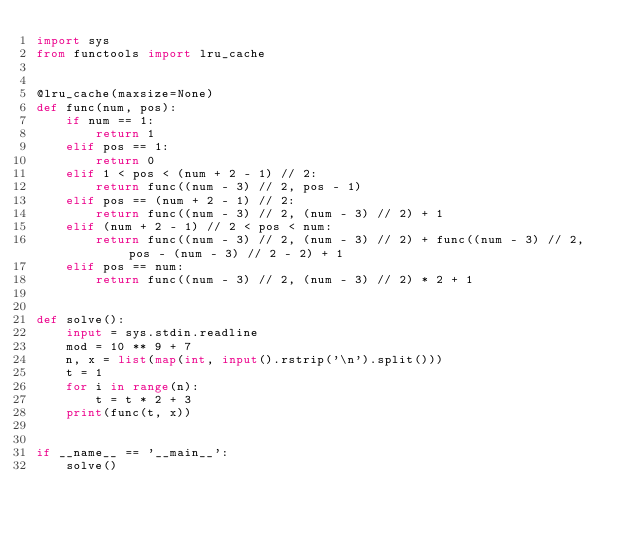<code> <loc_0><loc_0><loc_500><loc_500><_Python_>import sys
from functools import lru_cache


@lru_cache(maxsize=None)
def func(num, pos):
    if num == 1:
        return 1
    elif pos == 1:
        return 0
    elif 1 < pos < (num + 2 - 1) // 2:
        return func((num - 3) // 2, pos - 1)
    elif pos == (num + 2 - 1) // 2:
        return func((num - 3) // 2, (num - 3) // 2) + 1
    elif (num + 2 - 1) // 2 < pos < num:
        return func((num - 3) // 2, (num - 3) // 2) + func((num - 3) // 2, pos - (num - 3) // 2 - 2) + 1
    elif pos == num:
        return func((num - 3) // 2, (num - 3) // 2) * 2 + 1


def solve():
    input = sys.stdin.readline
    mod = 10 ** 9 + 7
    n, x = list(map(int, input().rstrip('\n').split()))
    t = 1
    for i in range(n):
        t = t * 2 + 3
    print(func(t, x))


if __name__ == '__main__':
    solve()
</code> 